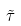Convert formula to latex. <formula><loc_0><loc_0><loc_500><loc_500>\tilde { \tau }</formula> 